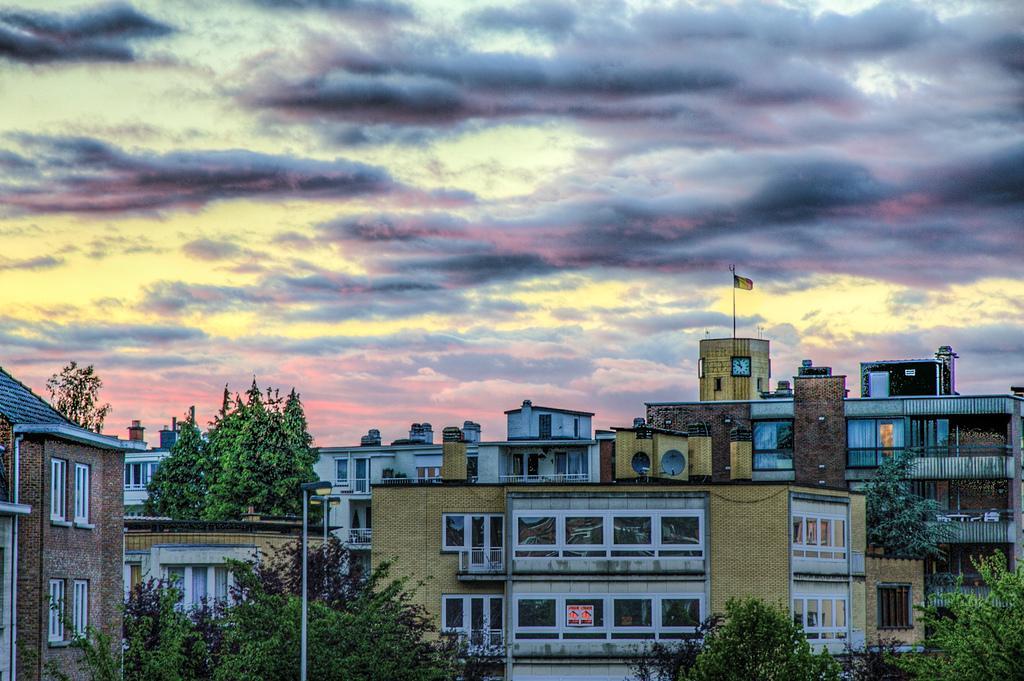Could you give a brief overview of what you see in this image? In this image I can see few buildings, windows, trees, flagpoles and the sky. 